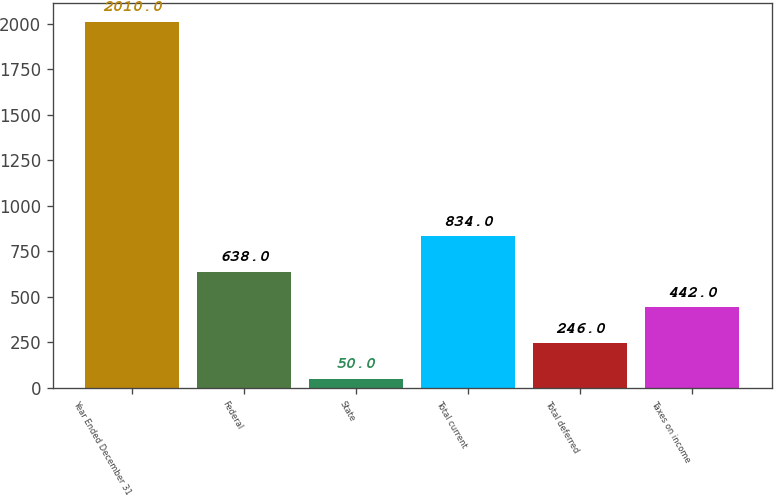Convert chart to OTSL. <chart><loc_0><loc_0><loc_500><loc_500><bar_chart><fcel>Year Ended December 31<fcel>Federal<fcel>State<fcel>Total current<fcel>Total deferred<fcel>Taxes on income<nl><fcel>2010<fcel>638<fcel>50<fcel>834<fcel>246<fcel>442<nl></chart> 